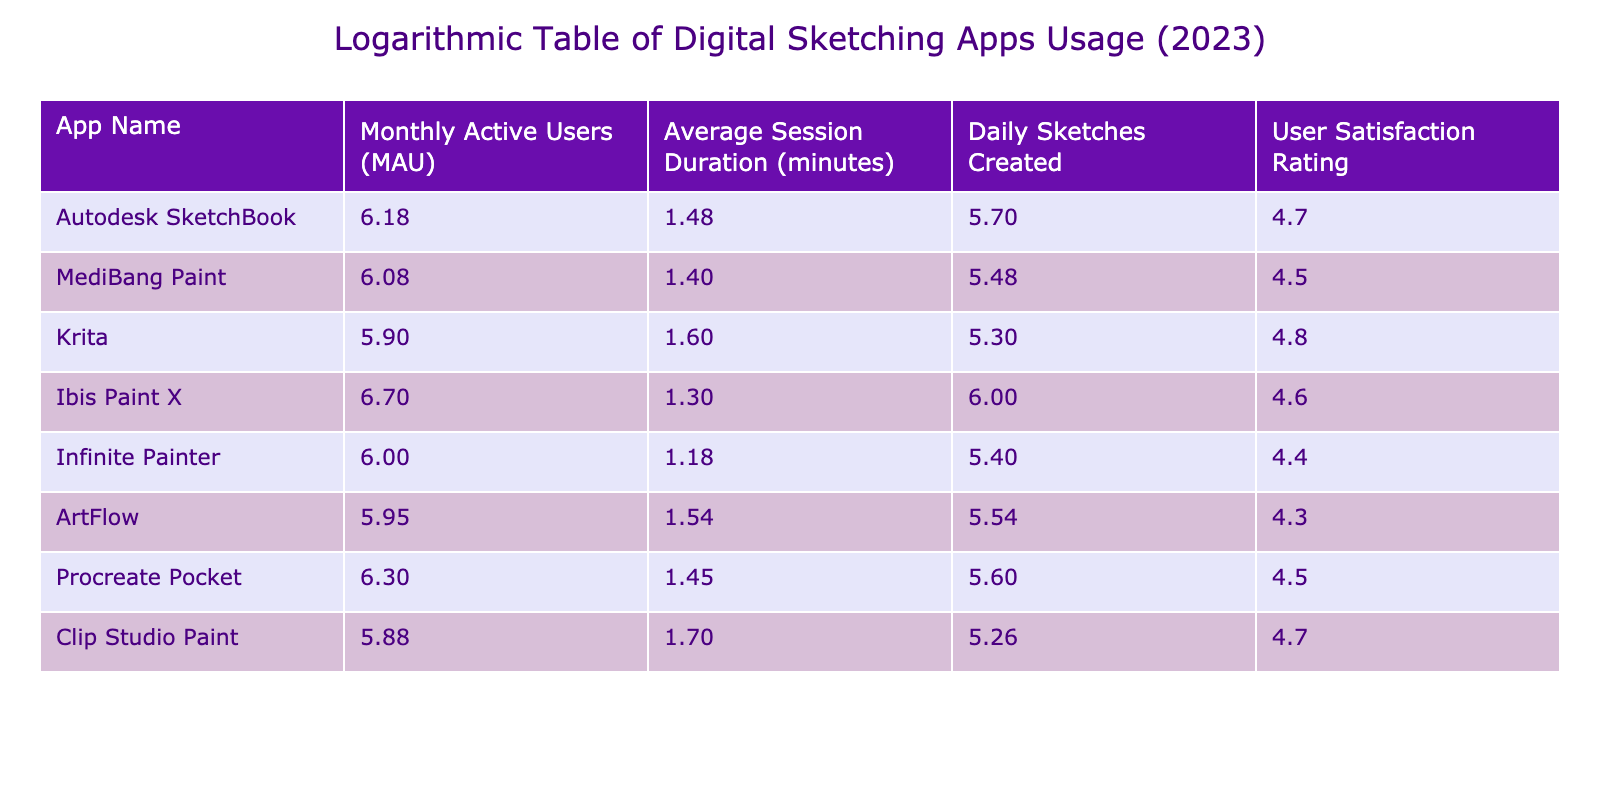What is the Monthly Active Users for Autodesk SketchBook? The table shows the row for Autodesk SketchBook, where the value under Monthly Active Users (MAU) is 1500000.
Answer: 1500000 Which app has the highest User Satisfaction Rating? By checking the User Satisfaction Rating column, Ibis Paint X has the highest rating of 4.6.
Answer: 4.6 How many Daily Sketches are created on average across all apps? To find the average, sum the Daily Sketches Created values (500000 + 300000 + 200000 + 1000000 + 250000 + 350000 + 400000 + 180000) which equals 2980000, then divide by the number of apps (8), resulting in an average of 372500.
Answer: 372500 Is Procreate Pocket rated higher than Infinite Painter in User Satisfaction? Looking at the User Satisfaction Rating column, Procreate Pocket has a rating of 4.5 while Infinite Painter has a rating of 4.4. Thus, Procreate Pocket is rated higher.
Answer: Yes What is the difference in Average Session Duration between Ibis Paint X and Krita? The Average Session Duration for Ibis Paint X is 20 minutes, and for Krita it is 40 minutes. The difference is 40 - 20 = 20 minutes.
Answer: 20 minutes How many Monthly Active Users do the top two apps have combined? The top two apps are Ibis Paint X with 5000000 and Procreate Pocket with 2000000. Summing these values gives 5000000 + 2000000 = 7000000.
Answer: 7000000 Which app has the lowest Daily Sketches Created? Checking the Daily Sketches Created column, Infinite Painter has the lowest value at 250000.
Answer: 250000 Do more users prefer Krita compared to Autodesk SketchBook based on Monthly Active Users? Comparing the Monthly Active Users, Krita has 800000 users while Autodesk SketchBook has 1500000 users. Therefore, more users prefer Autodesk SketchBook.
Answer: No What is the highest value of Average Session Duration among the apps listed? Reviewing the Average Session Duration column, the highest value is 50 minutes for Clip Studio Paint.
Answer: 50 minutes 